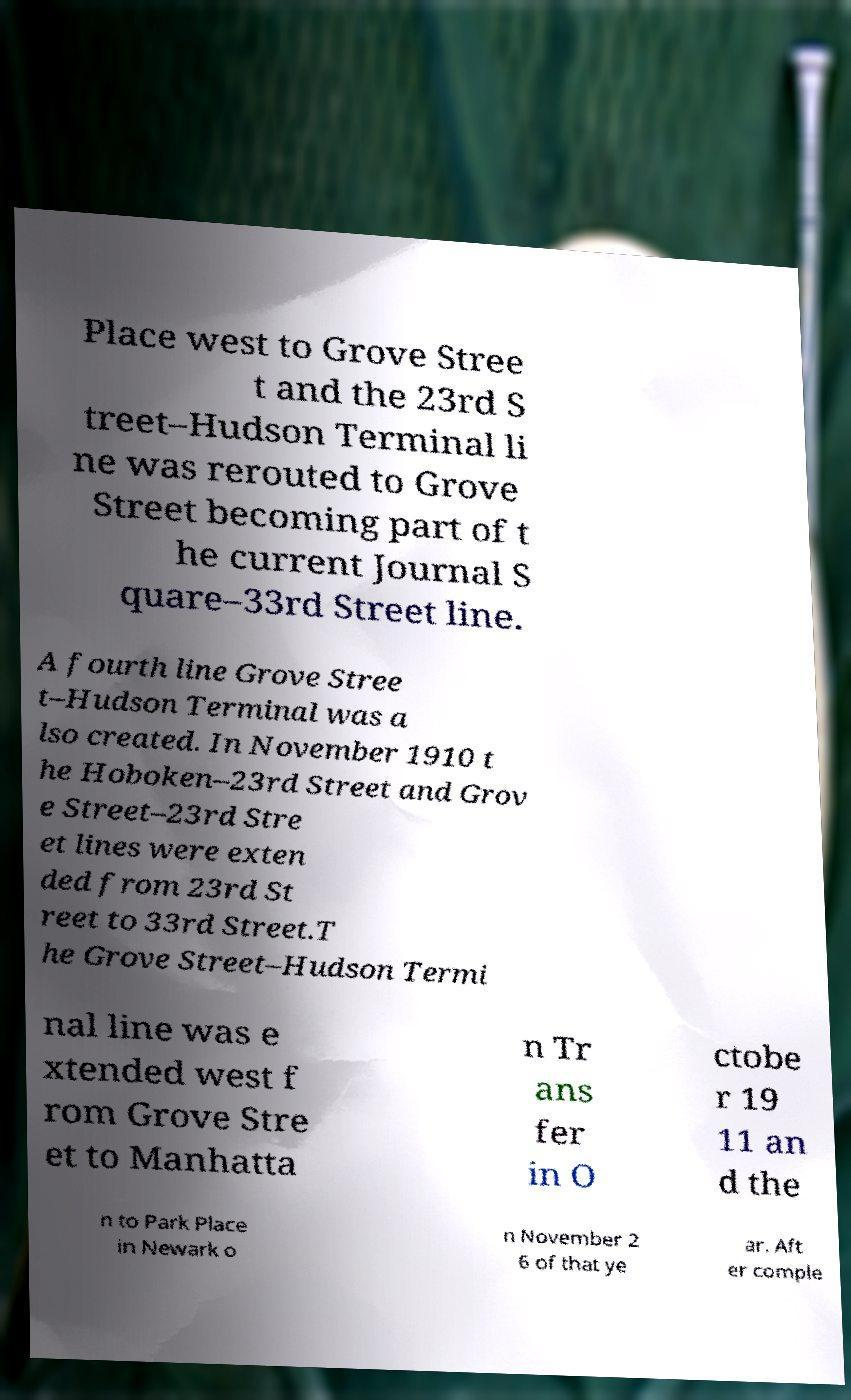I need the written content from this picture converted into text. Can you do that? Place west to Grove Stree t and the 23rd S treet–Hudson Terminal li ne was rerouted to Grove Street becoming part of t he current Journal S quare–33rd Street line. A fourth line Grove Stree t–Hudson Terminal was a lso created. In November 1910 t he Hoboken–23rd Street and Grov e Street–23rd Stre et lines were exten ded from 23rd St reet to 33rd Street.T he Grove Street–Hudson Termi nal line was e xtended west f rom Grove Stre et to Manhatta n Tr ans fer in O ctobe r 19 11 an d the n to Park Place in Newark o n November 2 6 of that ye ar. Aft er comple 